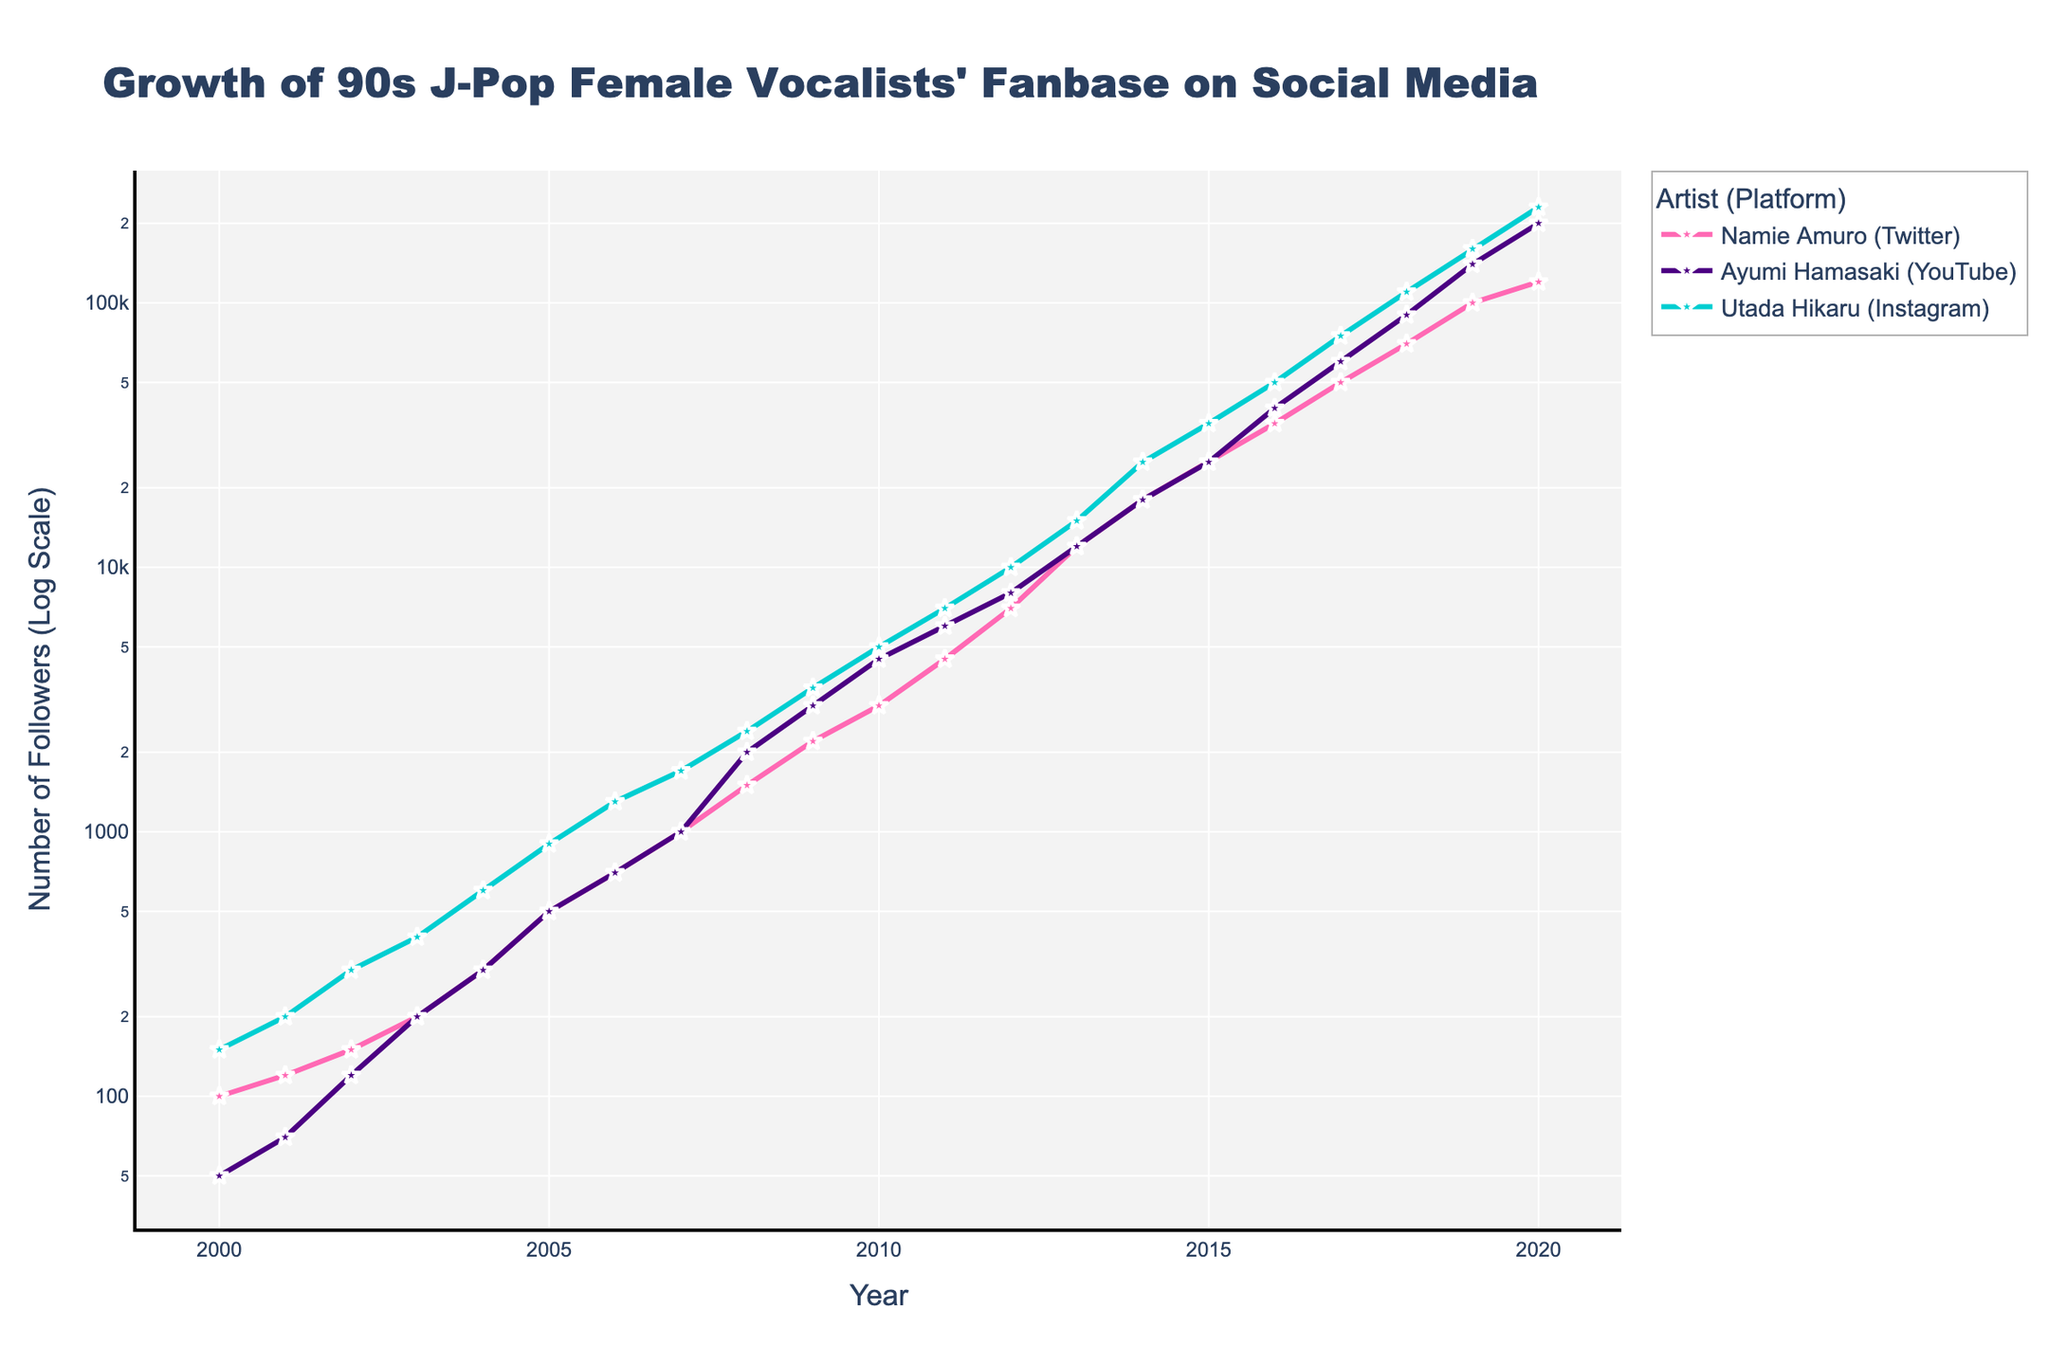What is the title of the figure? The title is displayed at the top of the figure, which is usually bold and larger in font size compared to other text elements.
Answer: "Growth of 90s J-Pop Female Vocalists' Fanbase on Social Media" How many artists are present in the figure? The figure presents multiple trends, each represented by a different color and legend entry. Count the distinct legend entries to determine the number of artists.
Answer: 3 Which artist has the highest number of followers in 2020? Look at the end points (2020) of each line on the y-axis to find the artist with the highest follower count.
Answer: Utada Hikaru What social media platform does Ayumi Hamasaki primarily use, according to the figure? Refer to the legend where each artist's name is followed by their social media platform.
Answer: YouTube Which year shows the steepest increase in the number of followers for Namie Amuro? Look for the year where the slope of Namie Amuro's trend line is steepest by visual inspection.
Answer: 2012-2013 How does Utada Hikaru's follower growth rate on Instagram from 2016 to 2018 compare to her growth rate from 2018 to 2020? Compare the slope of the trend line for Utada Hikaru between the two periods: 2016-2018 and 2018-2020.
Answer: The growth rate was higher in 2016-2018 What is the trend of Ayumi Hamasaki's follower count from 2008 to 2010? Identify the section of the trend line that corresponds to these years and describe its direction.
Answer: The follower count is increasing What is the overall pattern observed in the fanbase growth of these artists on social media? Describe the general trend seen in the lines representing each of the three artists.
Answer: Exponential growth for all three artists Which artist had the lowest number of followers in 2000, and what was the number? Compare the starting points (year 2000) of each line to identify the artist with the lowest value. Check the y-axis for the exact number.
Answer: Ayumi Hamasaki, 50 